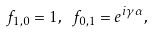Convert formula to latex. <formula><loc_0><loc_0><loc_500><loc_500>f _ { 1 , 0 } = 1 , \ f _ { 0 , 1 } = e ^ { i \gamma \alpha } ,</formula> 